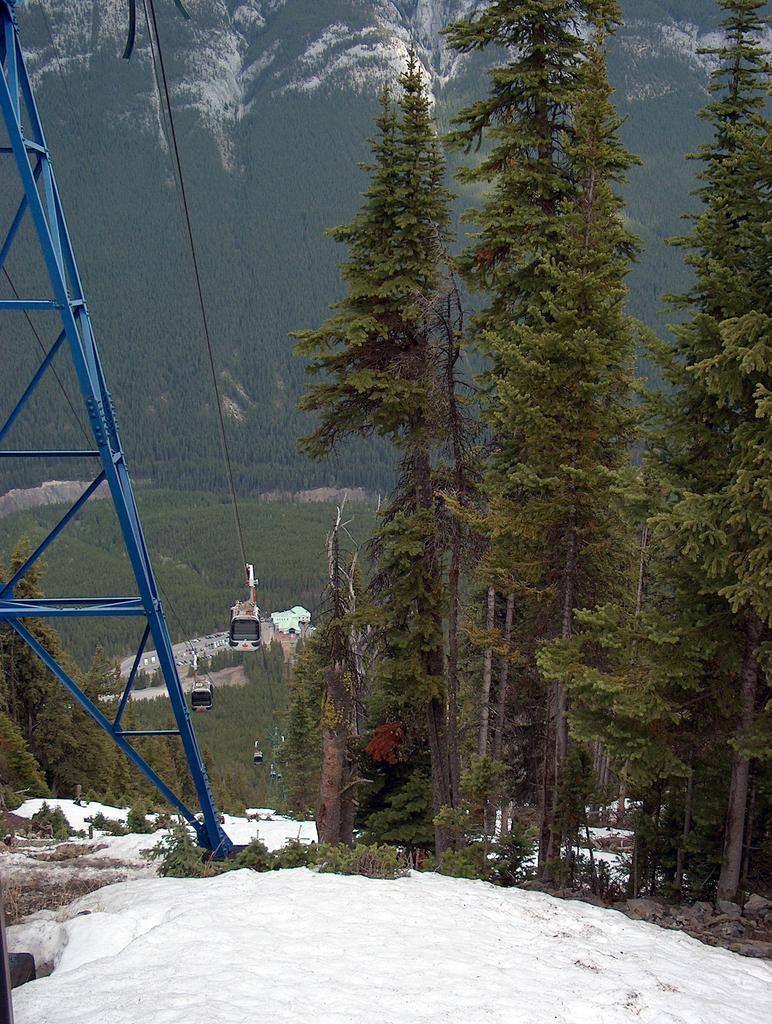How would you summarize this image in a sentence or two? On the right side of the image we can see snow and trees. On the left side of the image we can see ropeway, tower, trees. At the bottom of the image there is snow. In the background we can see trees and hills. 